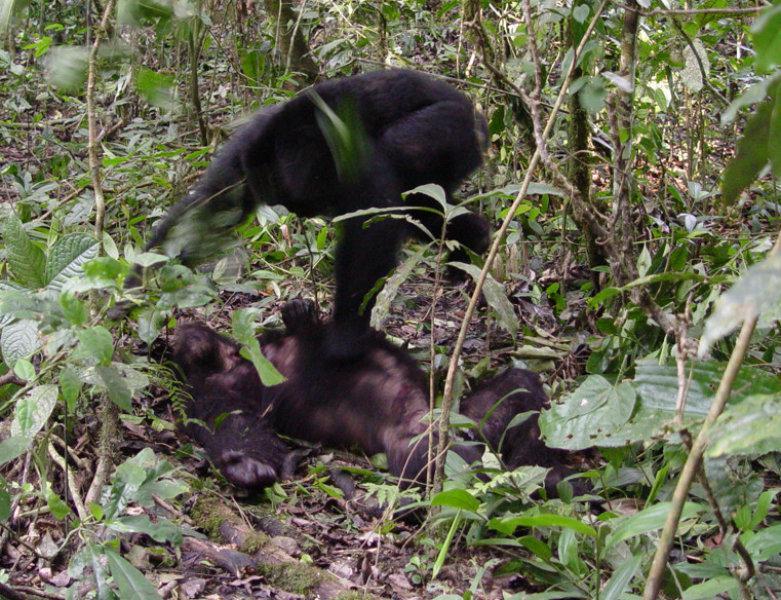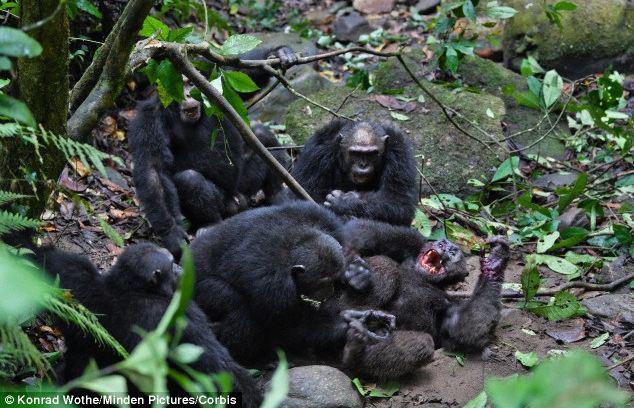The first image is the image on the left, the second image is the image on the right. Analyze the images presented: Is the assertion "there is a single chimp holding animal parts" valid? Answer yes or no. No. The first image is the image on the left, the second image is the image on the right. Examine the images to the left and right. Is the description "In one image there is a lone chimpanzee eating meat in the center of the image." accurate? Answer yes or no. No. 